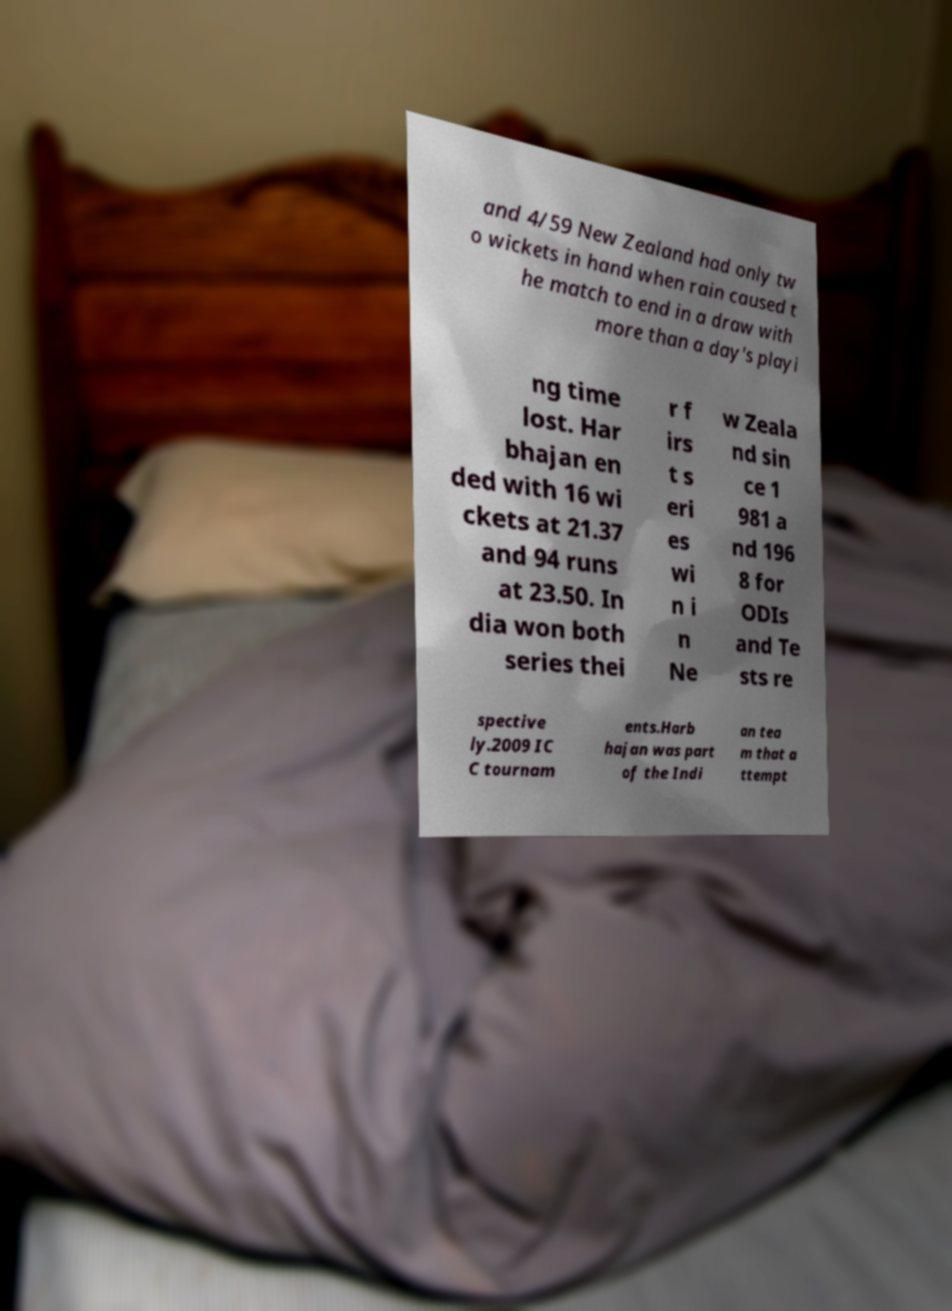Please read and relay the text visible in this image. What does it say? and 4/59 New Zealand had only tw o wickets in hand when rain caused t he match to end in a draw with more than a day's playi ng time lost. Har bhajan en ded with 16 wi ckets at 21.37 and 94 runs at 23.50. In dia won both series thei r f irs t s eri es wi n i n Ne w Zeala nd sin ce 1 981 a nd 196 8 for ODIs and Te sts re spective ly.2009 IC C tournam ents.Harb hajan was part of the Indi an tea m that a ttempt 